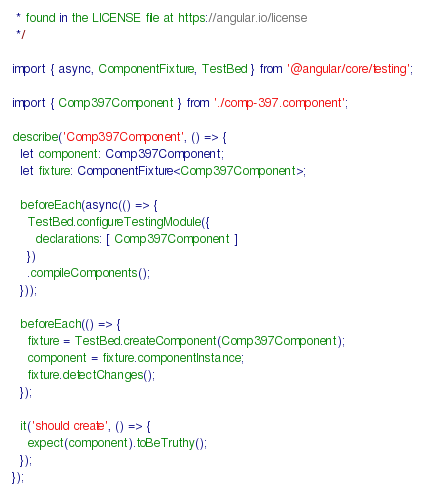<code> <loc_0><loc_0><loc_500><loc_500><_TypeScript_> * found in the LICENSE file at https://angular.io/license
 */

import { async, ComponentFixture, TestBed } from '@angular/core/testing';

import { Comp397Component } from './comp-397.component';

describe('Comp397Component', () => {
  let component: Comp397Component;
  let fixture: ComponentFixture<Comp397Component>;

  beforeEach(async(() => {
    TestBed.configureTestingModule({
      declarations: [ Comp397Component ]
    })
    .compileComponents();
  }));

  beforeEach(() => {
    fixture = TestBed.createComponent(Comp397Component);
    component = fixture.componentInstance;
    fixture.detectChanges();
  });

  it('should create', () => {
    expect(component).toBeTruthy();
  });
});
</code> 